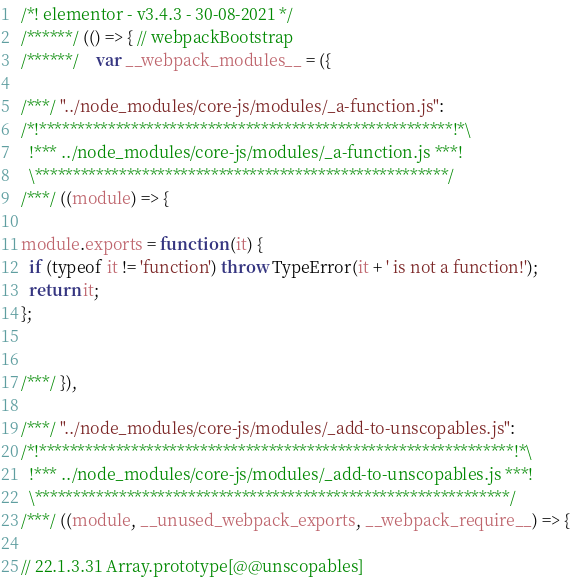<code> <loc_0><loc_0><loc_500><loc_500><_JavaScript_>/*! elementor - v3.4.3 - 30-08-2021 */
/******/ (() => { // webpackBootstrap
/******/ 	var __webpack_modules__ = ({

/***/ "../node_modules/core-js/modules/_a-function.js":
/*!******************************************************!*\
  !*** ../node_modules/core-js/modules/_a-function.js ***!
  \******************************************************/
/***/ ((module) => {

module.exports = function (it) {
  if (typeof it != 'function') throw TypeError(it + ' is not a function!');
  return it;
};


/***/ }),

/***/ "../node_modules/core-js/modules/_add-to-unscopables.js":
/*!**************************************************************!*\
  !*** ../node_modules/core-js/modules/_add-to-unscopables.js ***!
  \**************************************************************/
/***/ ((module, __unused_webpack_exports, __webpack_require__) => {

// 22.1.3.31 Array.prototype[@@unscopables]</code> 